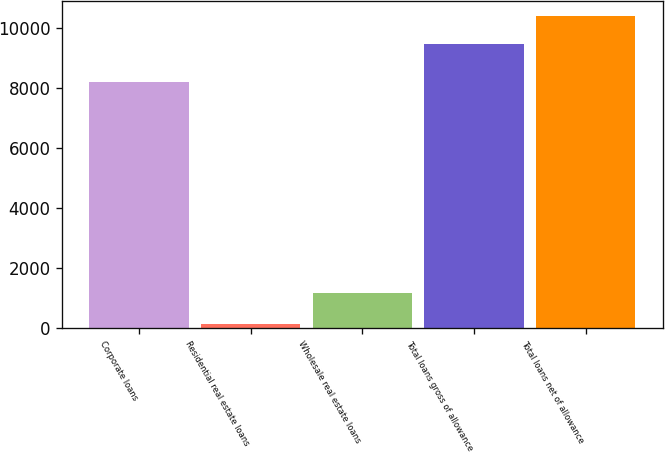<chart> <loc_0><loc_0><loc_500><loc_500><bar_chart><fcel>Corporate loans<fcel>Residential real estate loans<fcel>Wholesale real estate loans<fcel>Total loans gross of allowance<fcel>Total loans net of allowance<nl><fcel>8200<fcel>114<fcel>1144<fcel>9458<fcel>10392.4<nl></chart> 